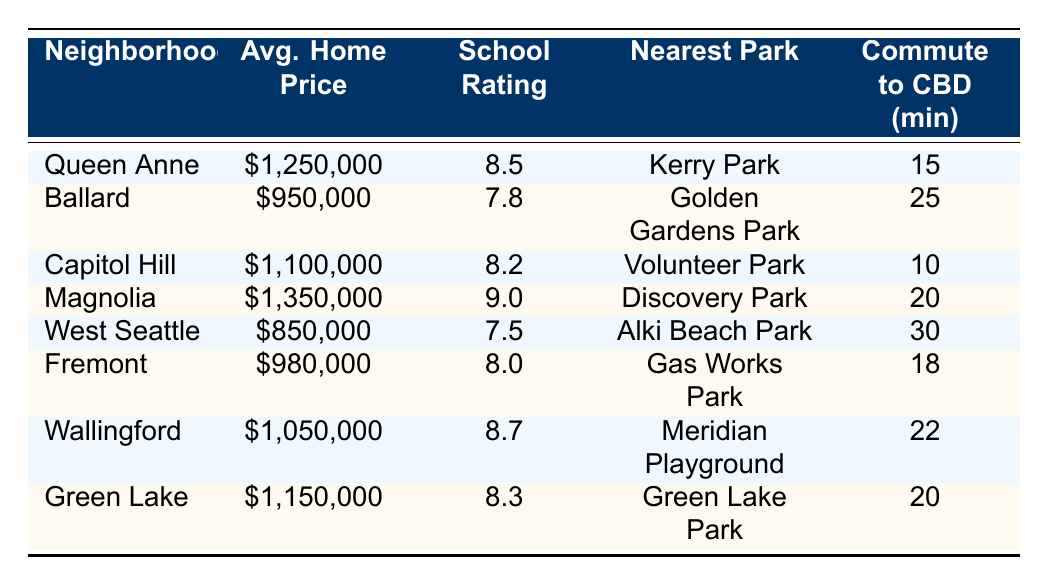What is the average home price in Capitol Hill? The average home price listed for Capitol Hill in the table is $1,100,000.
Answer: $1,100,000 Which neighborhood has the highest school rating? Looking at the school ratings, Magnolia has the highest rating at 9.0.
Answer: Magnolia What is the average home price across all neighborhoods? To calculate the average home price, we first add all the average prices: (1,250,000 + 950,000 + 1,100,000 + 1,350,000 + 850,000 + 980,000 + 1,050,000 + 1,150,000) = 8,730,000. There are 8 neighborhoods, so the average is 8,730,000 / 8 = 1,091,250.
Answer: $1,091,250 Does Ballard have a higher average home price than West Seattle? The average home price for Ballard is $950,000, while West Seattle's average home price is $850,000. Since $950,000 is greater than $850,000, the answer is yes.
Answer: Yes How many neighborhoods have an average home price above $1,000,000? The neighborhoods with prices above $1,000,000 are Queen Anne ($1,250,000), Capitol Hill ($1,100,000), Magnolia ($1,350,000), Wallingford ($1,050,000), and Green Lake ($1,150,000). That makes a total of 5 neighborhoods.
Answer: 5 If you combine the average home prices of Fremont and Ballard, how much do you get? The average home price for Fremont is $980,000, and for Ballard, it is $950,000. Adding these two gives $980,000 + $950,000 = $1,930,000.
Answer: $1,930,000 Is the nearest park in Green Lake closer to the CBD compared to the nearest park in Wallingford? Green Lake's nearest park has a commute time of 20 minutes to the CBD, while Wallingford has a commute time of 22 minutes. Since 20 minutes is less than 22 minutes, the answer is yes.
Answer: Yes What is the difference in average home prices between Magnolia and Ballard? Calculating the difference, Magnolia's price is $1,350,000, and Ballard's is $950,000. The difference is $1,350,000 - $950,000 = $400,000.
Answer: $400,000 Which neighborhood has the longest commute to the CBD? The table shows that West Seattle has the longest commute time listed at 30 minutes.
Answer: West Seattle 